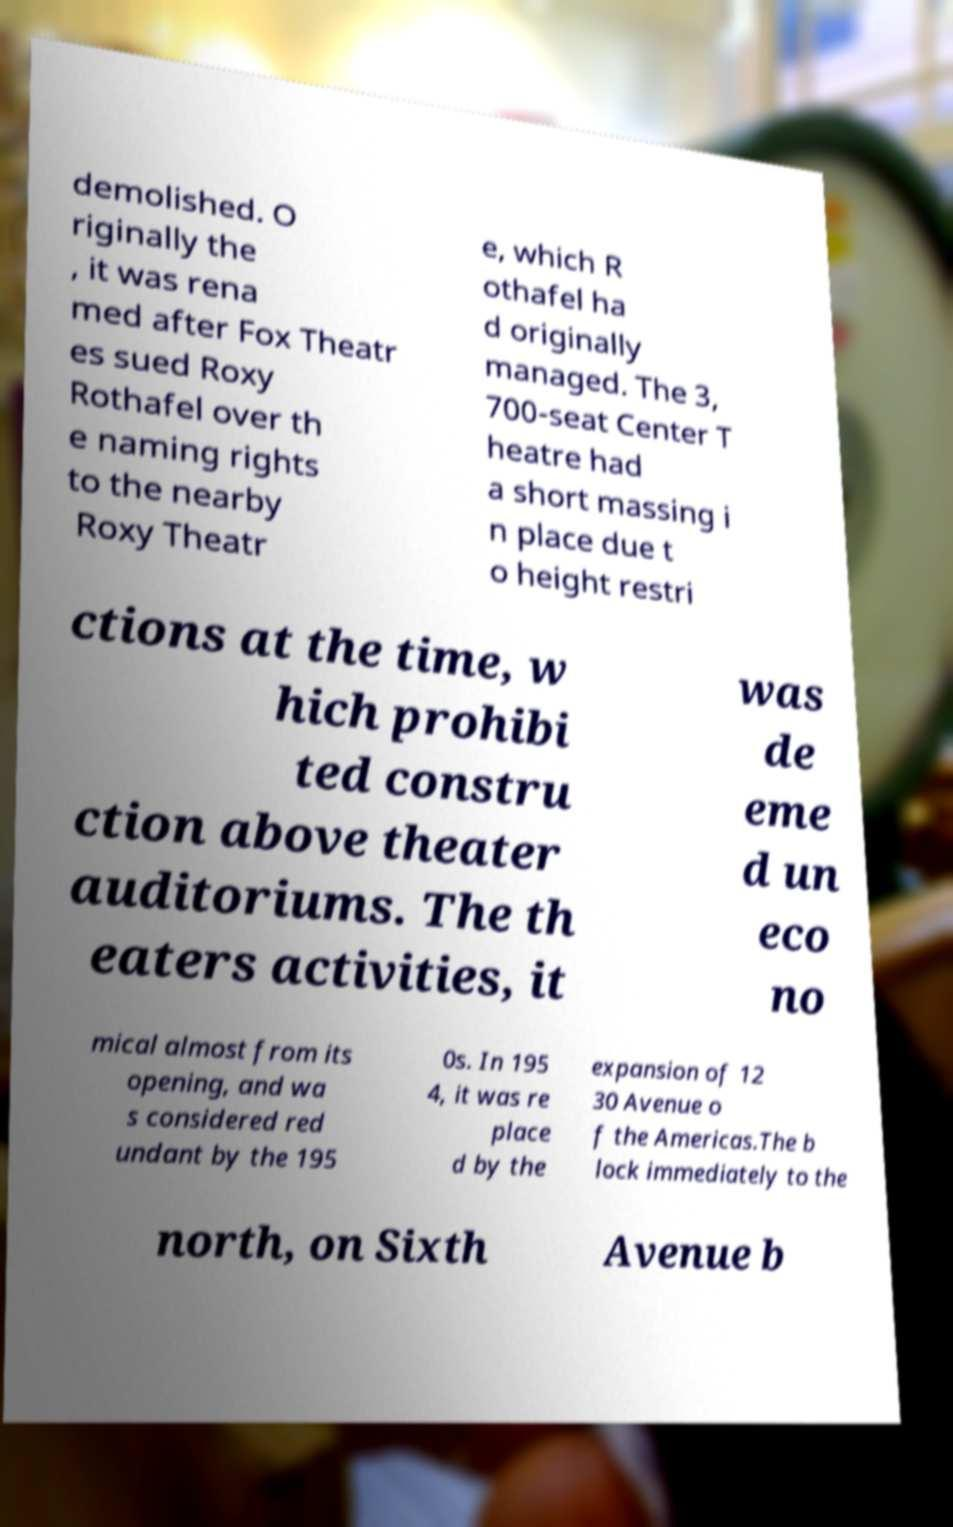Can you read and provide the text displayed in the image?This photo seems to have some interesting text. Can you extract and type it out for me? demolished. O riginally the , it was rena med after Fox Theatr es sued Roxy Rothafel over th e naming rights to the nearby Roxy Theatr e, which R othafel ha d originally managed. The 3, 700-seat Center T heatre had a short massing i n place due t o height restri ctions at the time, w hich prohibi ted constru ction above theater auditoriums. The th eaters activities, it was de eme d un eco no mical almost from its opening, and wa s considered red undant by the 195 0s. In 195 4, it was re place d by the expansion of 12 30 Avenue o f the Americas.The b lock immediately to the north, on Sixth Avenue b 